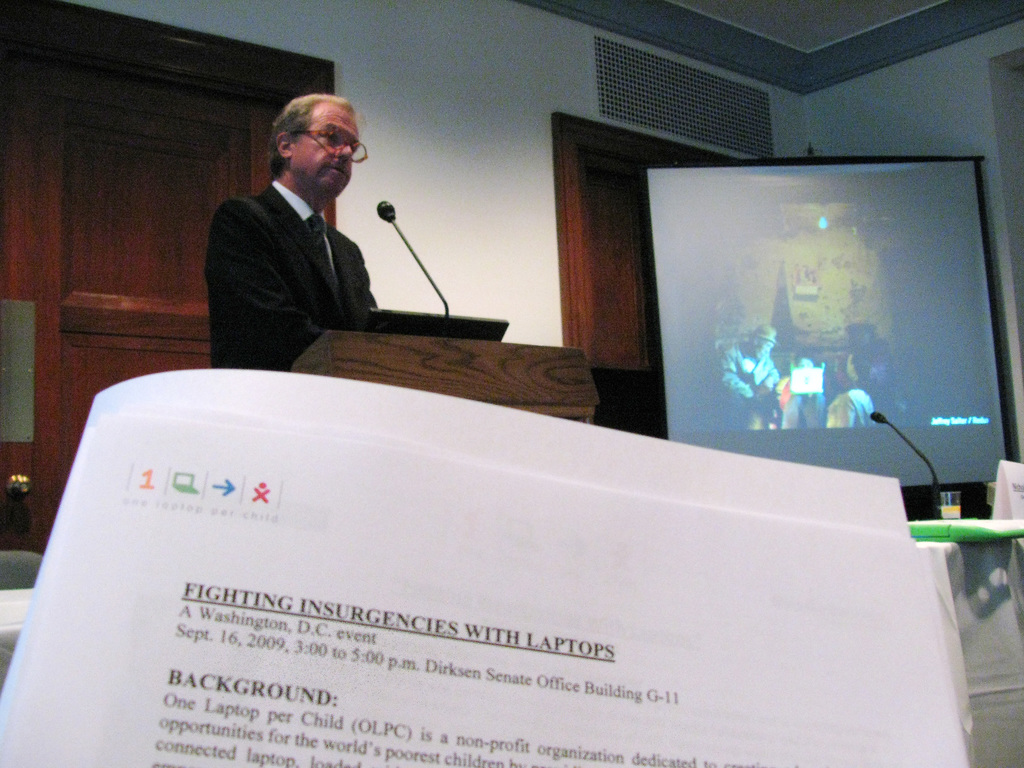What is the impact of events like the one shown in the image on public policy or public opinion? Events such as the one depicted, particularly being held at significant venues like the Senate Office Building, can have substantial impact on shaping public policy and influencing public opinion. By demonstrating the applications and success stories of initiatives like OLPC, these events can garner support and potentially influence legislative actions and funding allocations aimed at integrating technology more deeply into education and societal development projects. 